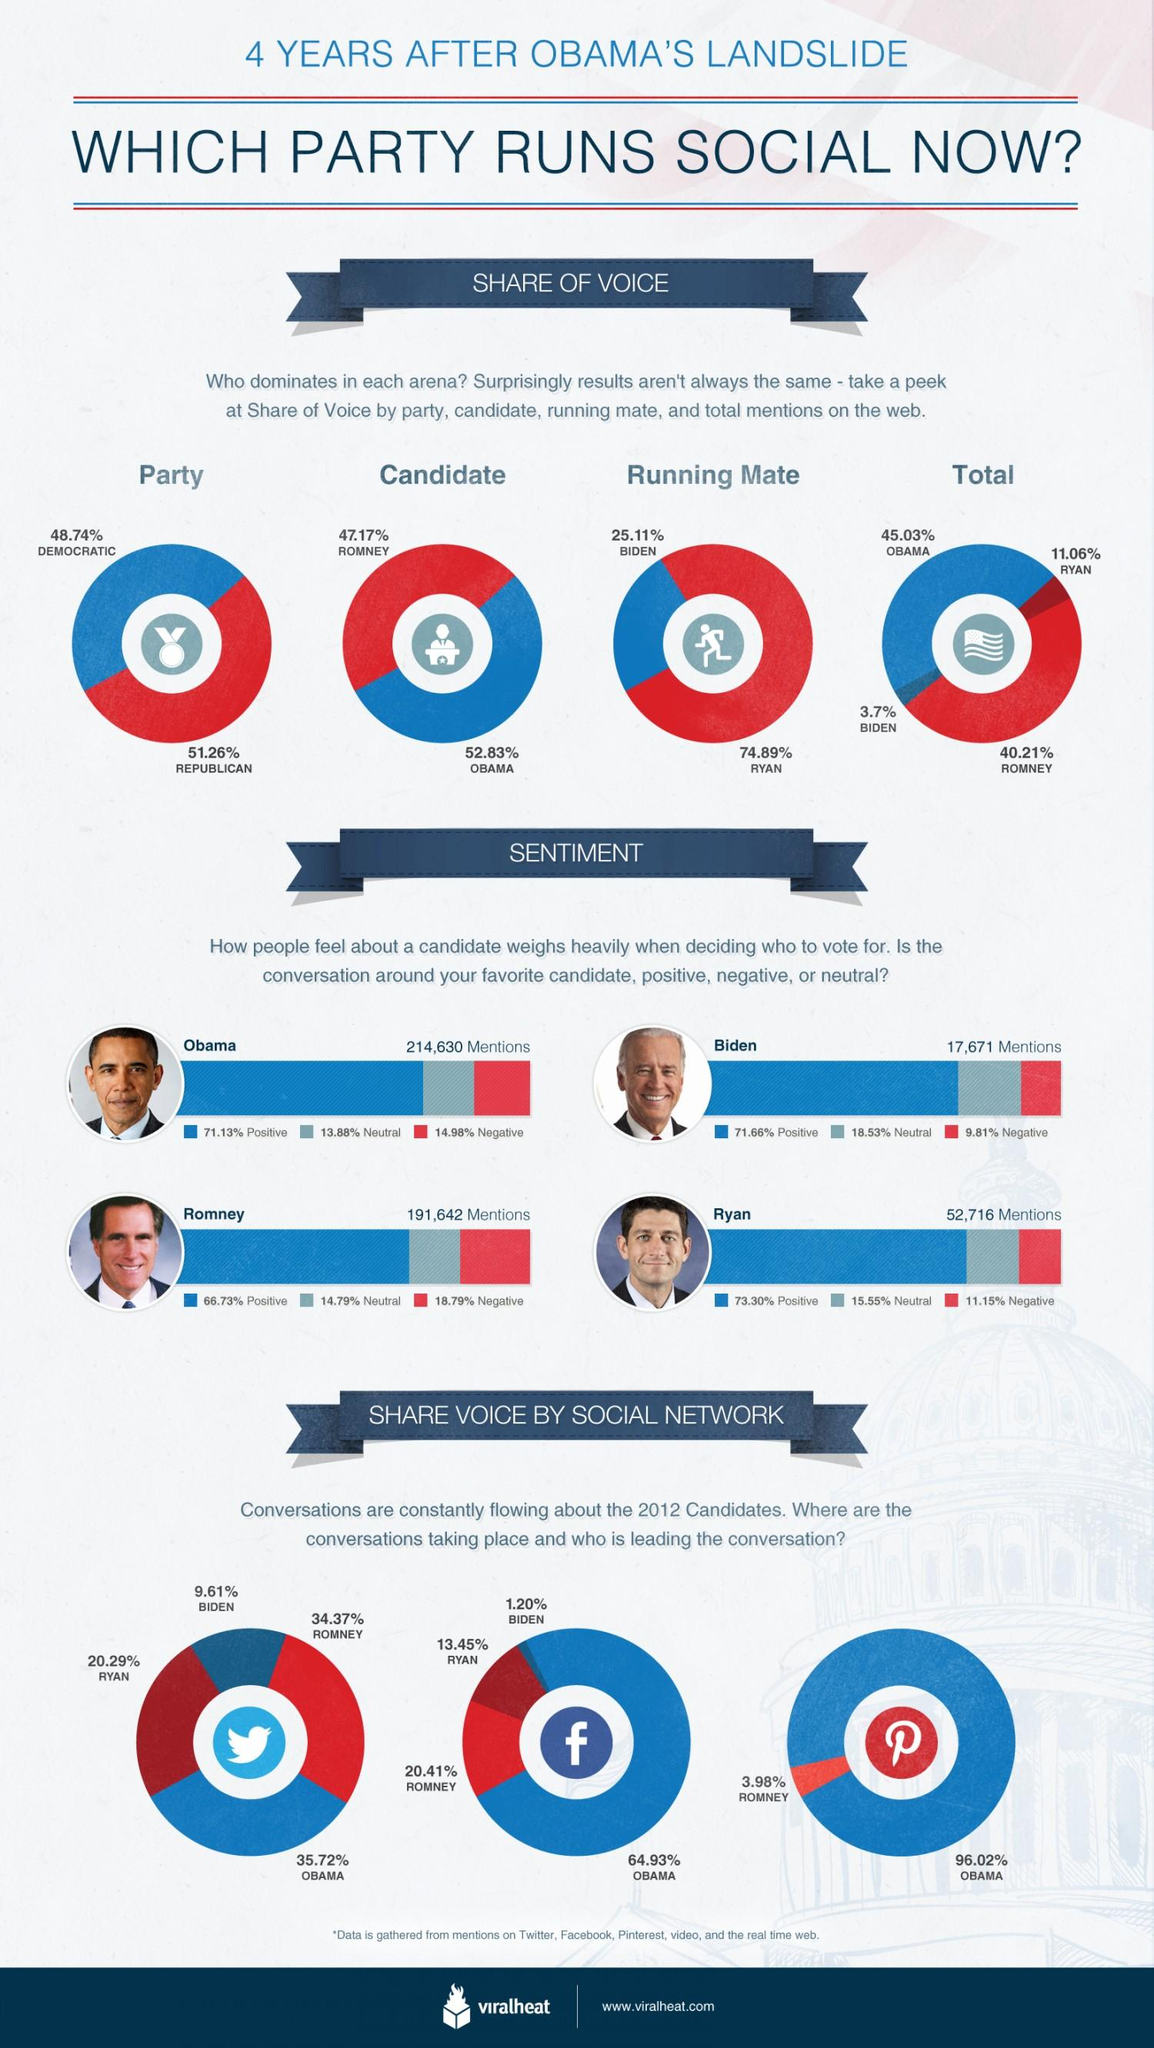Mention a couple of crucial points in this snapshot. Obama is considered to be more influential on social media than Romney, Biden, and Ryan, based on the given information. Mitt Romney's running mate is Paul Ryan. The person who has had the highest percentage of negative mentions is Mitt Romney. According to the given information, Pinterest had the highest number of conversations about Obama on social media. Ryan has had the largest percentage share of positive mentions compared to the others. 